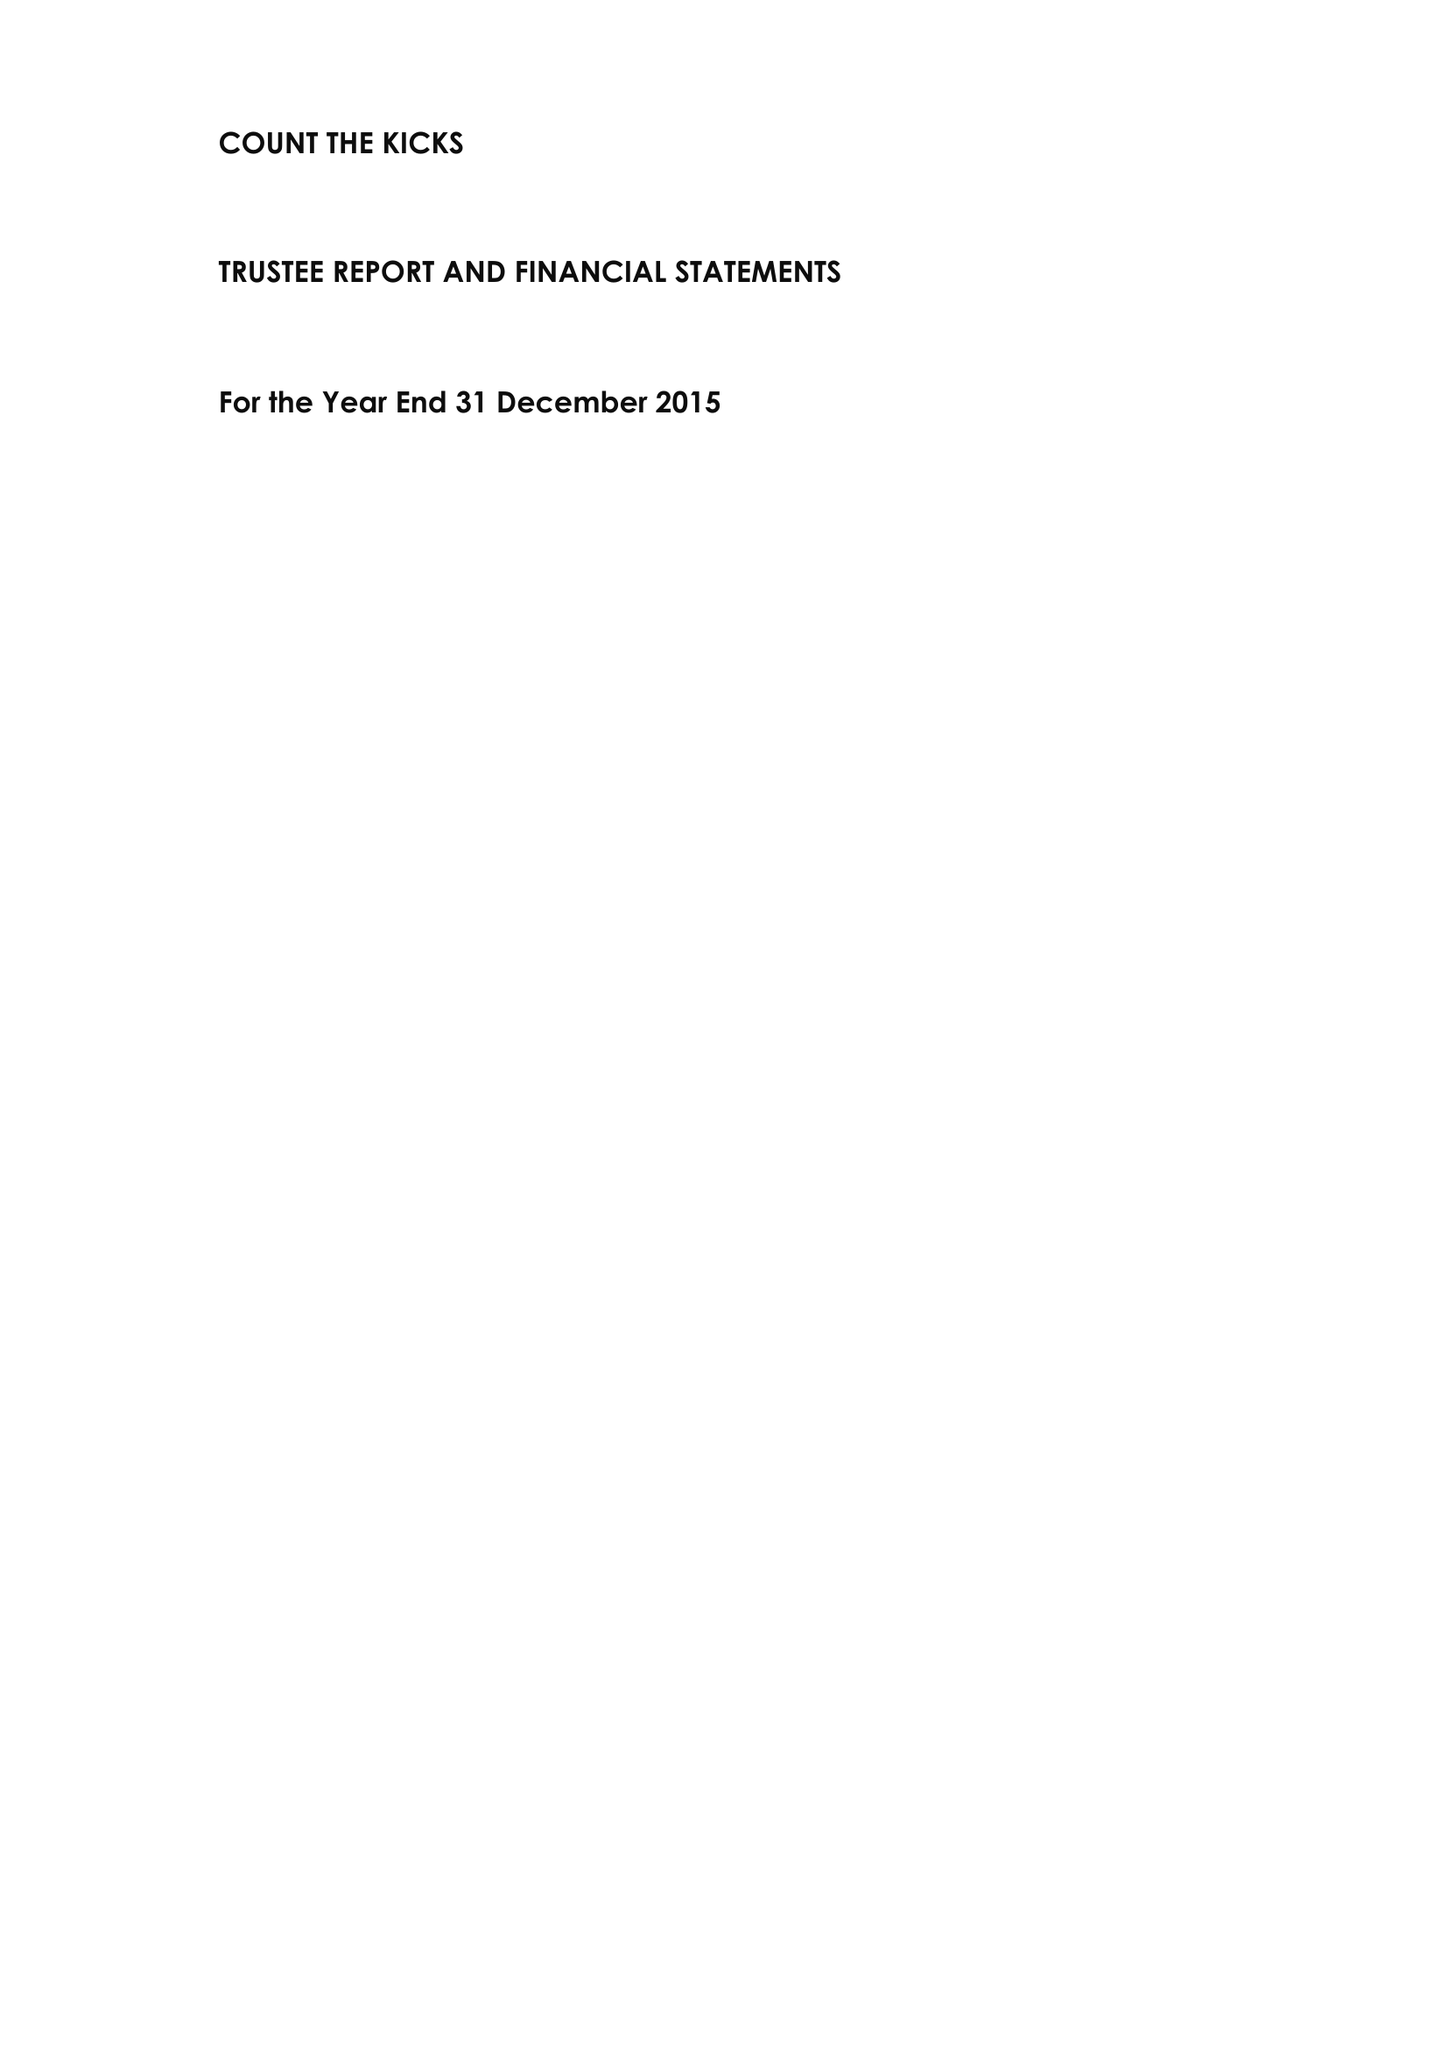What is the value for the report_date?
Answer the question using a single word or phrase. 2015-12-31 